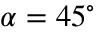<formula> <loc_0><loc_0><loc_500><loc_500>\alpha = 4 5 ^ { \circ }</formula> 